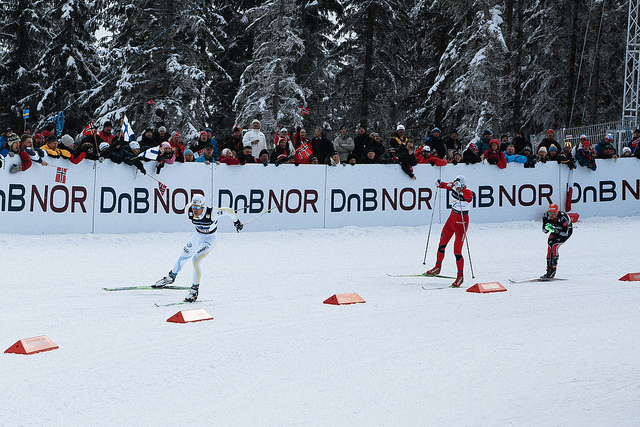<image>What major holiday was this event near? I'm not sure which major holiday this event was near. However, it could possibly be Christmas. What major holiday was this event near? I don't know what major holiday this event was near. It can be Christmas or winter. 